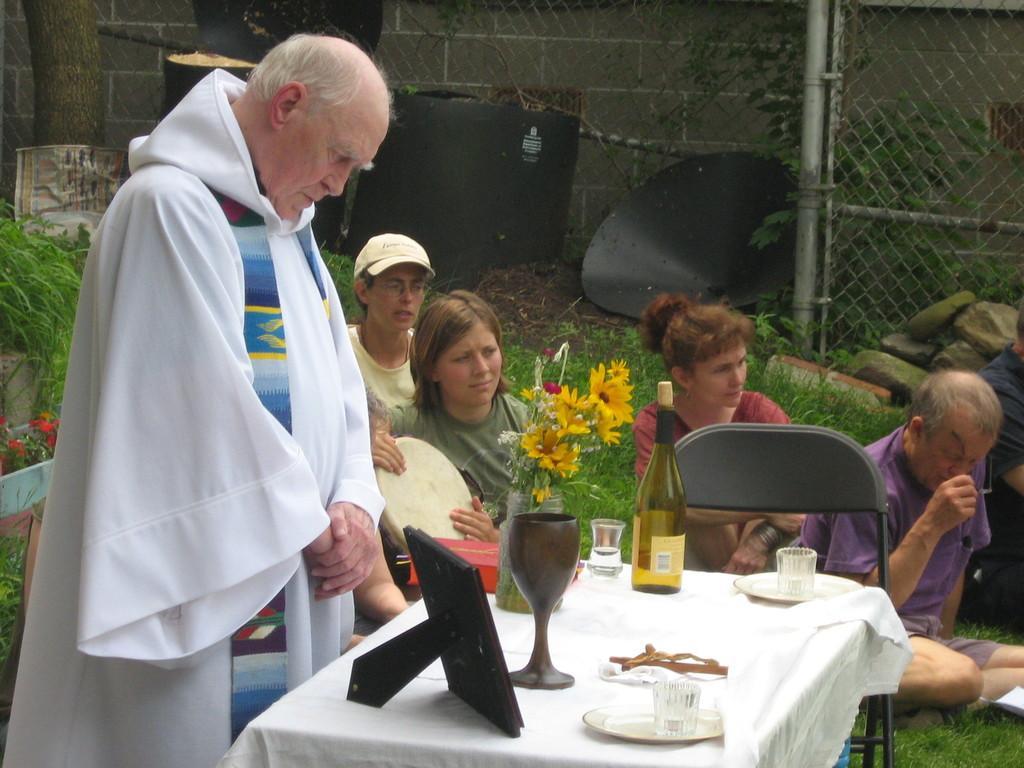Can you describe this image briefly? The image is inside the garden. In the image there are group of people sitting, on left side we can see a man wearing a white color dress is standing in front of a table. On table we can see bottle,glass,plate,cloth and a photo frame in background we can see a net fence,plants at bottom there is a grass. 